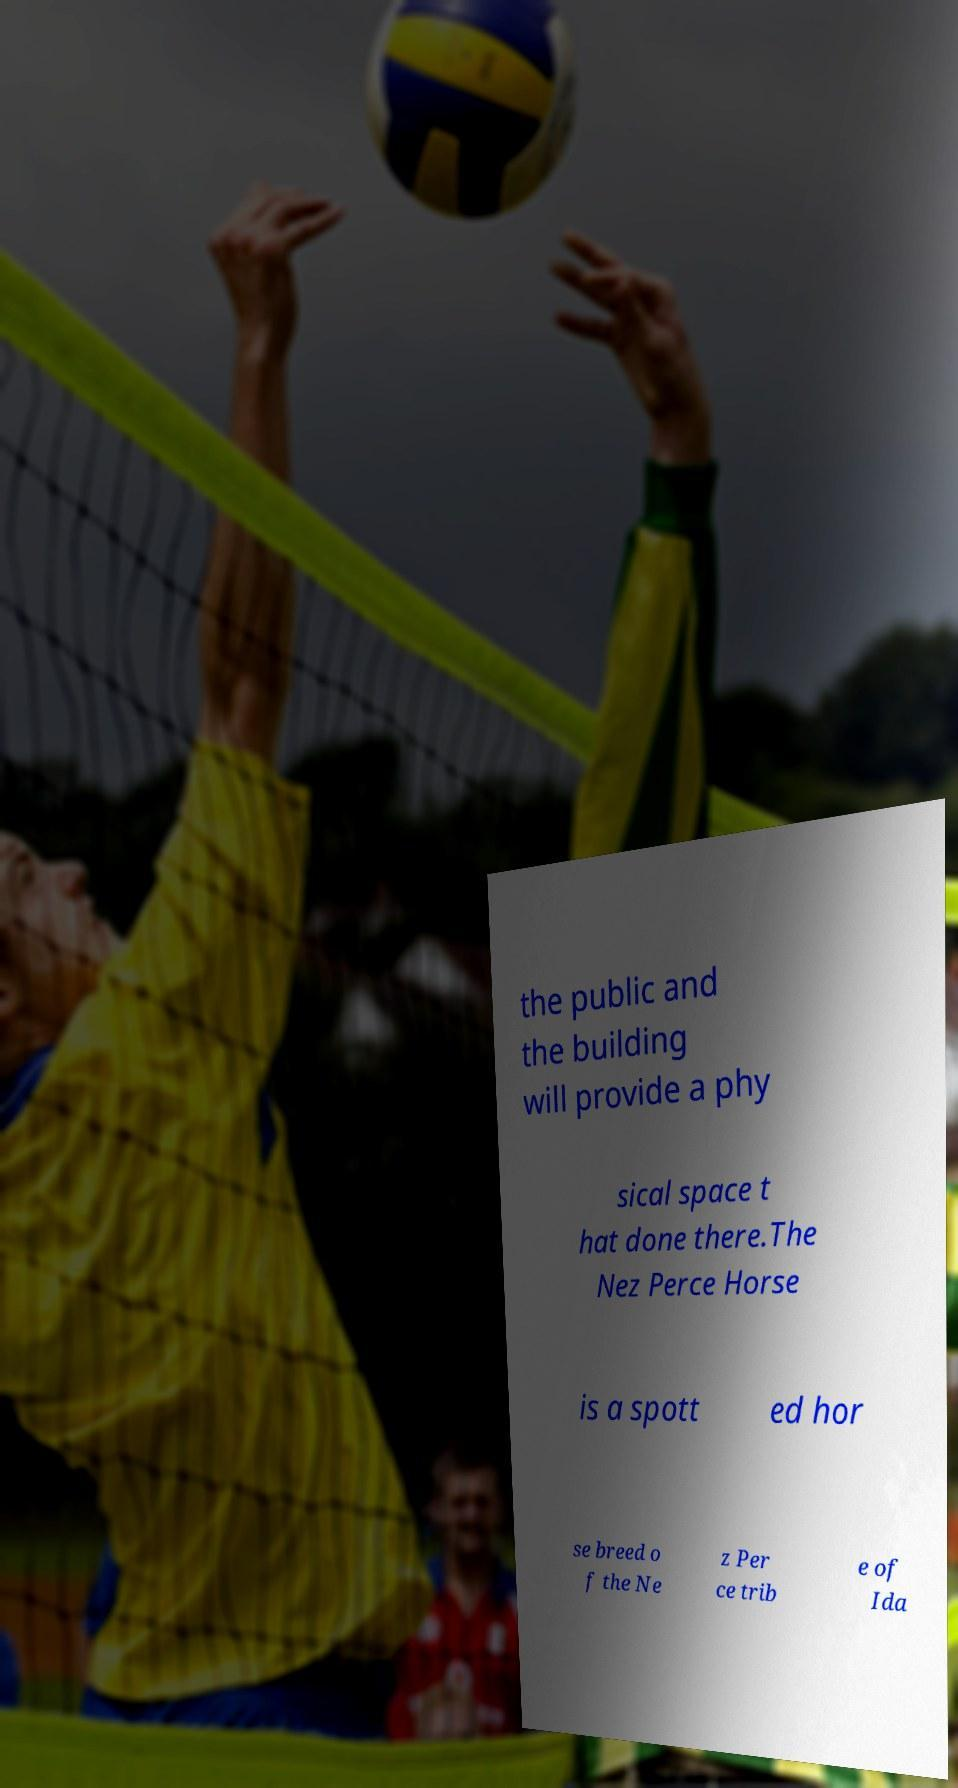Could you extract and type out the text from this image? the public and the building will provide a phy sical space t hat done there.The Nez Perce Horse is a spott ed hor se breed o f the Ne z Per ce trib e of Ida 